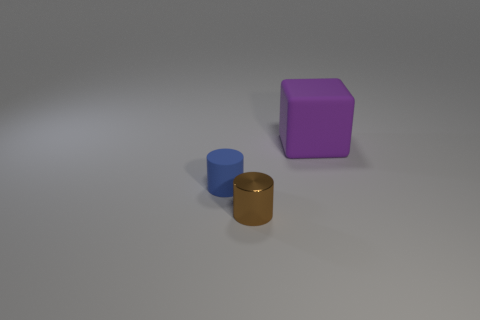Taking into consideration the lighting and shadows, what time of day or setting does this environment suggest? The lighting in the image is soft and diffuse, with mild shadows indicating an indoor setting with artificial lighting rather than natural sunlight. There are no clues suggesting a particular time of day. 